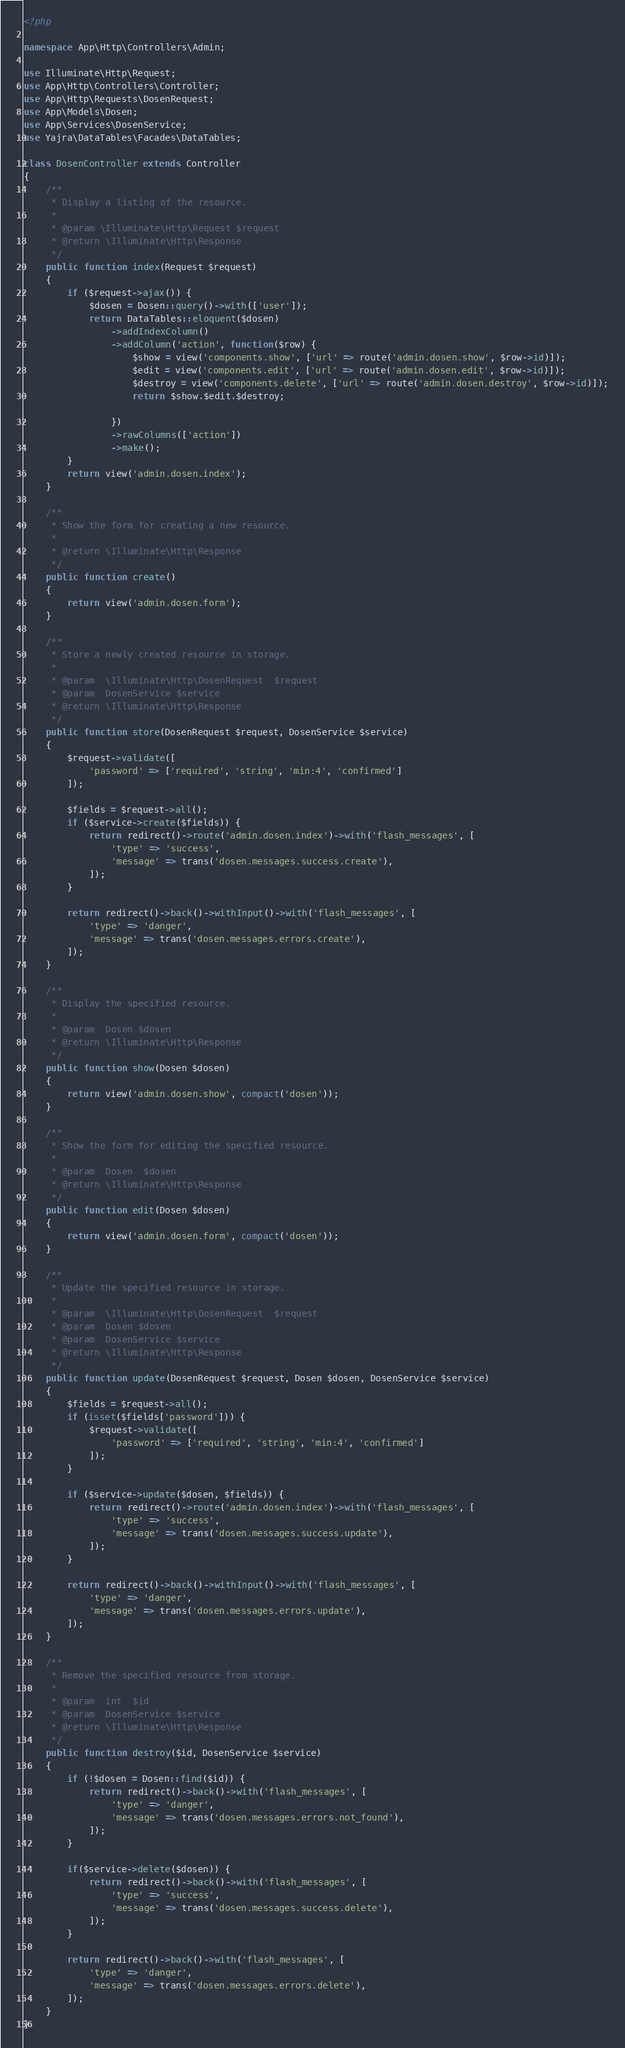<code> <loc_0><loc_0><loc_500><loc_500><_PHP_><?php

namespace App\Http\Controllers\Admin;

use Illuminate\Http\Request;
use App\Http\Controllers\Controller;
use App\Http\Requests\DosenRequest;
use App\Models\Dosen;
use App\Services\DosenService;
use Yajra\DataTables\Facades\DataTables;

class DosenController extends Controller
{
    /**
     * Display a listing of the resource.
     *
     * @param \Illuminate\Http\Request $request
     * @return \Illuminate\Http\Response
     */
    public function index(Request $request)
    {
        if ($request->ajax()) {
            $dosen = Dosen::query()->with(['user']);
            return DataTables::eloquent($dosen)
                ->addIndexColumn()
                ->addColumn('action', function($row) {
                    $show = view('components.show', ['url' => route('admin.dosen.show', $row->id)]);
                    $edit = view('components.edit', ['url' => route('admin.dosen.edit', $row->id)]);
                    $destroy = view('components.delete', ['url' => route('admin.dosen.destroy', $row->id)]);
                    return $show.$edit.$destroy;

                })
                ->rawColumns(['action'])
                ->make();
        }
        return view('admin.dosen.index');
    }

    /**
     * Show the form for creating a new resource.
     *
     * @return \Illuminate\Http\Response
     */
    public function create()
    {
        return view('admin.dosen.form');
    }

    /**
     * Store a newly created resource in storage.
     *
     * @param  \Illuminate\Http\DosenRequest  $request
     * @param  DosenService $service
     * @return \Illuminate\Http\Response
     */
    public function store(DosenRequest $request, DosenService $service)
    {
        $request->validate([
            'password' => ['required', 'string', 'min:4', 'confirmed']
        ]);

        $fields = $request->all();
        if ($service->create($fields)) {
            return redirect()->route('admin.dosen.index')->with('flash_messages', [
                'type' => 'success',
                'message' => trans('dosen.messages.success.create'),
            ]);
        }

        return redirect()->back()->withInput()->with('flash_messages', [
            'type' => 'danger',
            'message' => trans('dosen.messages.errors.create'),
        ]);
    }

    /**
     * Display the specified resource.
     *
     * @param  Dosen $dosen
     * @return \Illuminate\Http\Response
     */
    public function show(Dosen $dosen)
    {
        return view('admin.dosen.show', compact('dosen'));
    }

    /**
     * Show the form for editing the specified resource.
     *
     * @param  Dosen  $dosen
     * @return \Illuminate\Http\Response
     */
    public function edit(Dosen $dosen)
    {
        return view('admin.dosen.form', compact('dosen'));
    }

    /**
     * Update the specified resource in storage.
     *
     * @param  \Illuminate\Http\DosenRequest  $request
     * @param  Dosen $dosen
     * @param  DosenService $service
     * @return \Illuminate\Http\Response
     */
    public function update(DosenRequest $request, Dosen $dosen, DosenService $service)
    {
        $fields = $request->all();
        if (isset($fields['password'])) {
            $request->validate([
                'password' => ['required', 'string', 'min:4', 'confirmed']
            ]);
        }

        if ($service->update($dosen, $fields)) {
            return redirect()->route('admin.dosen.index')->with('flash_messages', [
                'type' => 'success',
                'message' => trans('dosen.messages.success.update'),
            ]);
        }

        return redirect()->back()->withInput()->with('flash_messages', [
            'type' => 'danger',
            'message' => trans('dosen.messages.errors.update'),
        ]);
    }

    /**
     * Remove the specified resource from storage.
     *
     * @param  int  $id
     * @param  DosenService $service
     * @return \Illuminate\Http\Response
     */
    public function destroy($id, DosenService $service)
    {
        if (!$dosen = Dosen::find($id)) {
            return redirect()->back()->with('flash_messages', [
                'type' => 'danger',
                'message' => trans('dosen.messages.errors.not_found'),
            ]);
        }

        if($service->delete($dosen)) {
            return redirect()->back()->with('flash_messages', [
                'type' => 'success',
                'message' => trans('dosen.messages.success.delete'),
            ]);
        }

        return redirect()->back()->with('flash_messages', [
            'type' => 'danger',
            'message' => trans('dosen.messages.errors.delete'),
        ]);
    }
}
</code> 